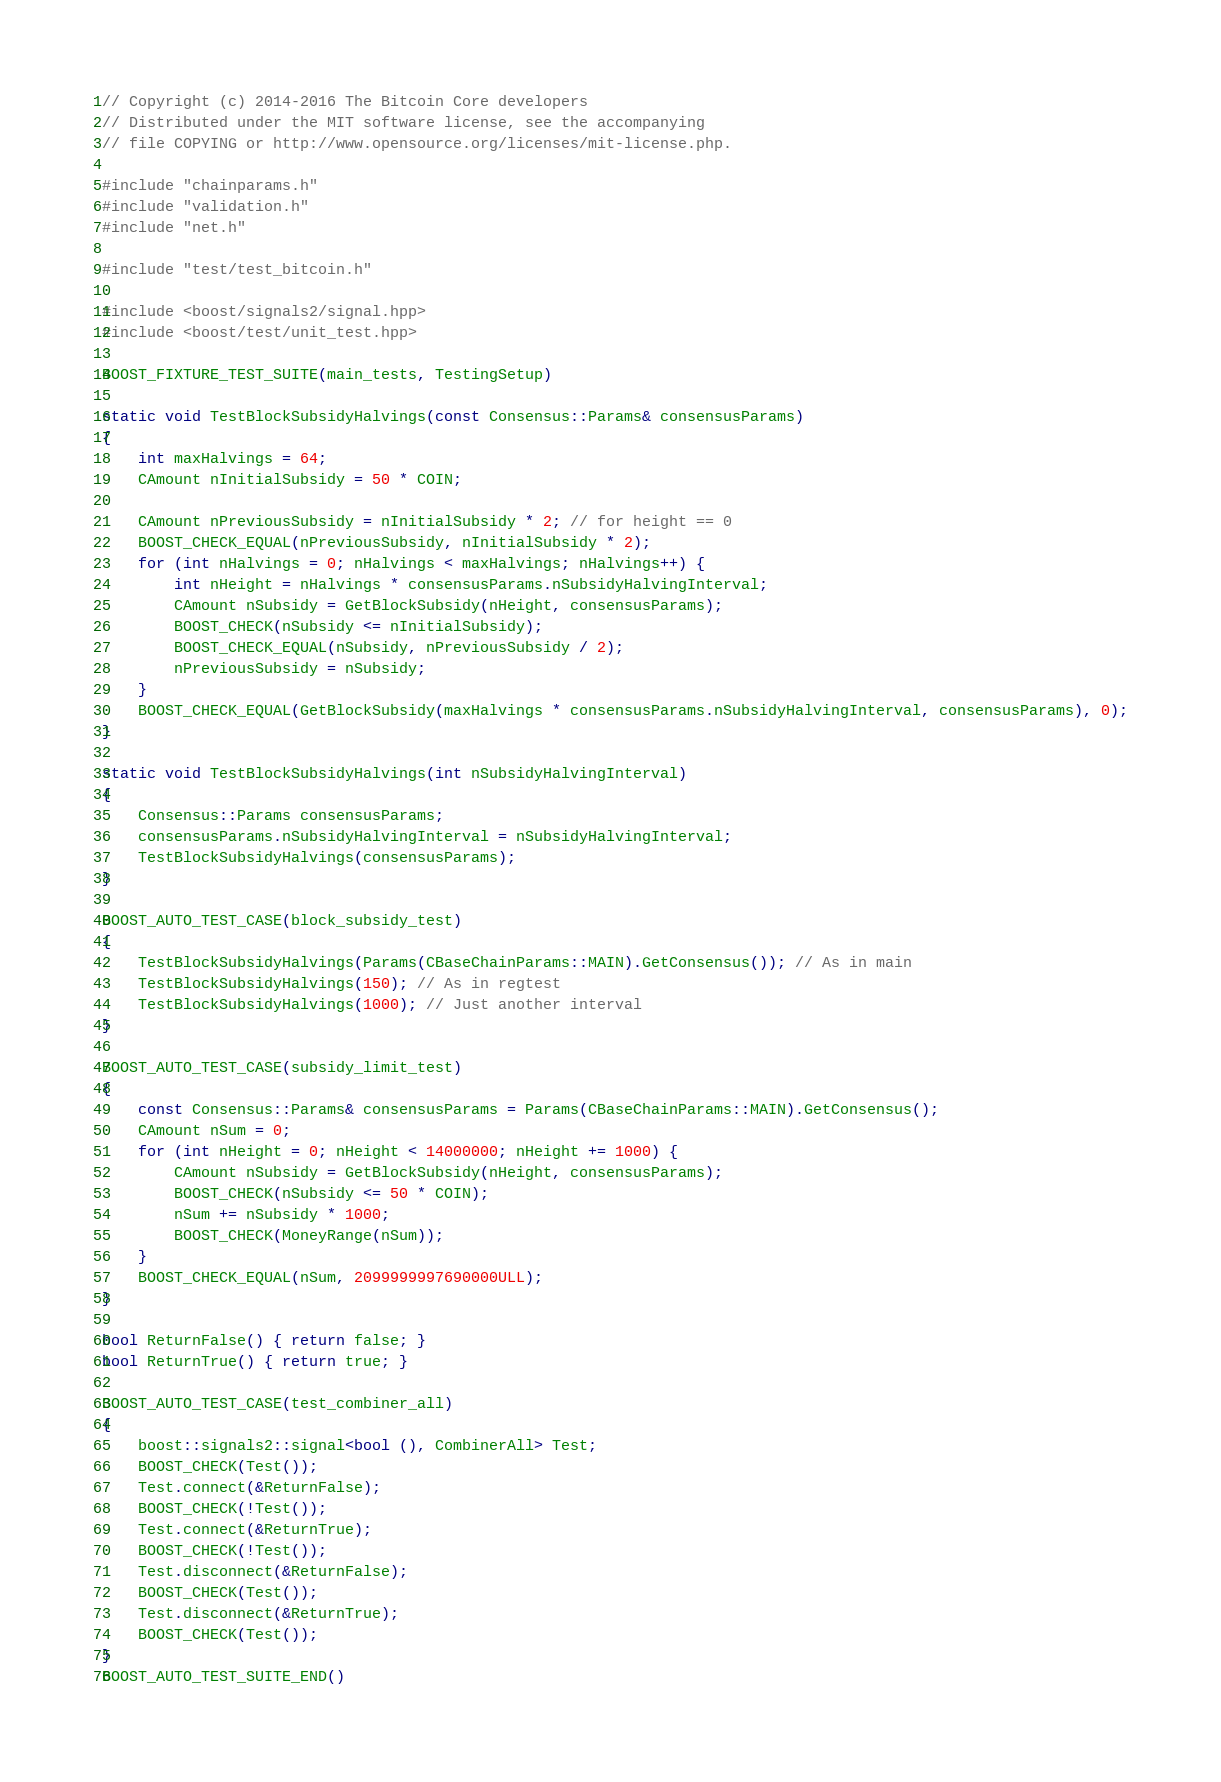Convert code to text. <code><loc_0><loc_0><loc_500><loc_500><_C++_>// Copyright (c) 2014-2016 The Bitcoin Core developers
// Distributed under the MIT software license, see the accompanying
// file COPYING or http://www.opensource.org/licenses/mit-license.php.

#include "chainparams.h"
#include "validation.h"
#include "net.h"

#include "test/test_bitcoin.h"

#include <boost/signals2/signal.hpp>
#include <boost/test/unit_test.hpp>

BOOST_FIXTURE_TEST_SUITE(main_tests, TestingSetup)

static void TestBlockSubsidyHalvings(const Consensus::Params& consensusParams)
{
    int maxHalvings = 64;
    CAmount nInitialSubsidy = 50 * COIN;

    CAmount nPreviousSubsidy = nInitialSubsidy * 2; // for height == 0
    BOOST_CHECK_EQUAL(nPreviousSubsidy, nInitialSubsidy * 2);
    for (int nHalvings = 0; nHalvings < maxHalvings; nHalvings++) {
        int nHeight = nHalvings * consensusParams.nSubsidyHalvingInterval;
        CAmount nSubsidy = GetBlockSubsidy(nHeight, consensusParams);
        BOOST_CHECK(nSubsidy <= nInitialSubsidy);
        BOOST_CHECK_EQUAL(nSubsidy, nPreviousSubsidy / 2);
        nPreviousSubsidy = nSubsidy;
    }
    BOOST_CHECK_EQUAL(GetBlockSubsidy(maxHalvings * consensusParams.nSubsidyHalvingInterval, consensusParams), 0);
}

static void TestBlockSubsidyHalvings(int nSubsidyHalvingInterval)
{
    Consensus::Params consensusParams;
    consensusParams.nSubsidyHalvingInterval = nSubsidyHalvingInterval;
    TestBlockSubsidyHalvings(consensusParams);
}

BOOST_AUTO_TEST_CASE(block_subsidy_test)
{
    TestBlockSubsidyHalvings(Params(CBaseChainParams::MAIN).GetConsensus()); // As in main
    TestBlockSubsidyHalvings(150); // As in regtest
    TestBlockSubsidyHalvings(1000); // Just another interval
}

BOOST_AUTO_TEST_CASE(subsidy_limit_test)
{
    const Consensus::Params& consensusParams = Params(CBaseChainParams::MAIN).GetConsensus();
    CAmount nSum = 0;
    for (int nHeight = 0; nHeight < 14000000; nHeight += 1000) {
        CAmount nSubsidy = GetBlockSubsidy(nHeight, consensusParams);
        BOOST_CHECK(nSubsidy <= 50 * COIN);
        nSum += nSubsidy * 1000;
        BOOST_CHECK(MoneyRange(nSum));
    }
    BOOST_CHECK_EQUAL(nSum, 2099999997690000ULL);
}

bool ReturnFalse() { return false; }
bool ReturnTrue() { return true; }

BOOST_AUTO_TEST_CASE(test_combiner_all)
{
    boost::signals2::signal<bool (), CombinerAll> Test;
    BOOST_CHECK(Test());
    Test.connect(&ReturnFalse);
    BOOST_CHECK(!Test());
    Test.connect(&ReturnTrue);
    BOOST_CHECK(!Test());
    Test.disconnect(&ReturnFalse);
    BOOST_CHECK(Test());
    Test.disconnect(&ReturnTrue);
    BOOST_CHECK(Test());
}
BOOST_AUTO_TEST_SUITE_END()
</code> 